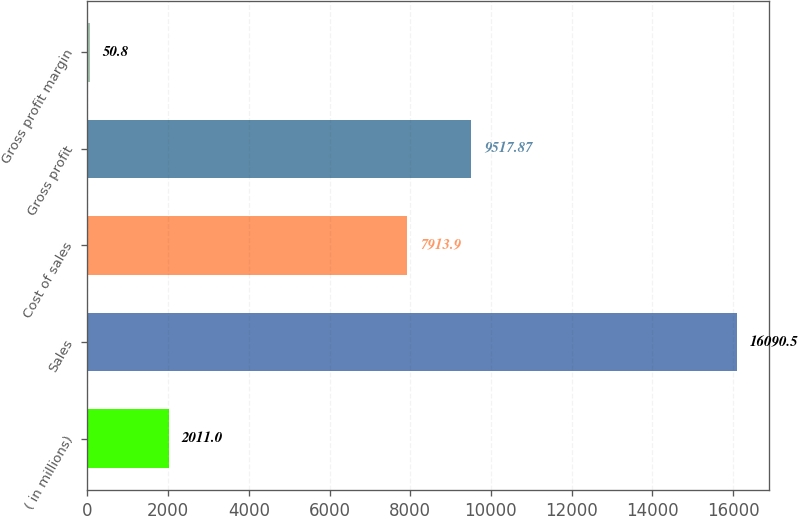Convert chart. <chart><loc_0><loc_0><loc_500><loc_500><bar_chart><fcel>( in millions)<fcel>Sales<fcel>Cost of sales<fcel>Gross profit<fcel>Gross profit margin<nl><fcel>2011<fcel>16090.5<fcel>7913.9<fcel>9517.87<fcel>50.8<nl></chart> 